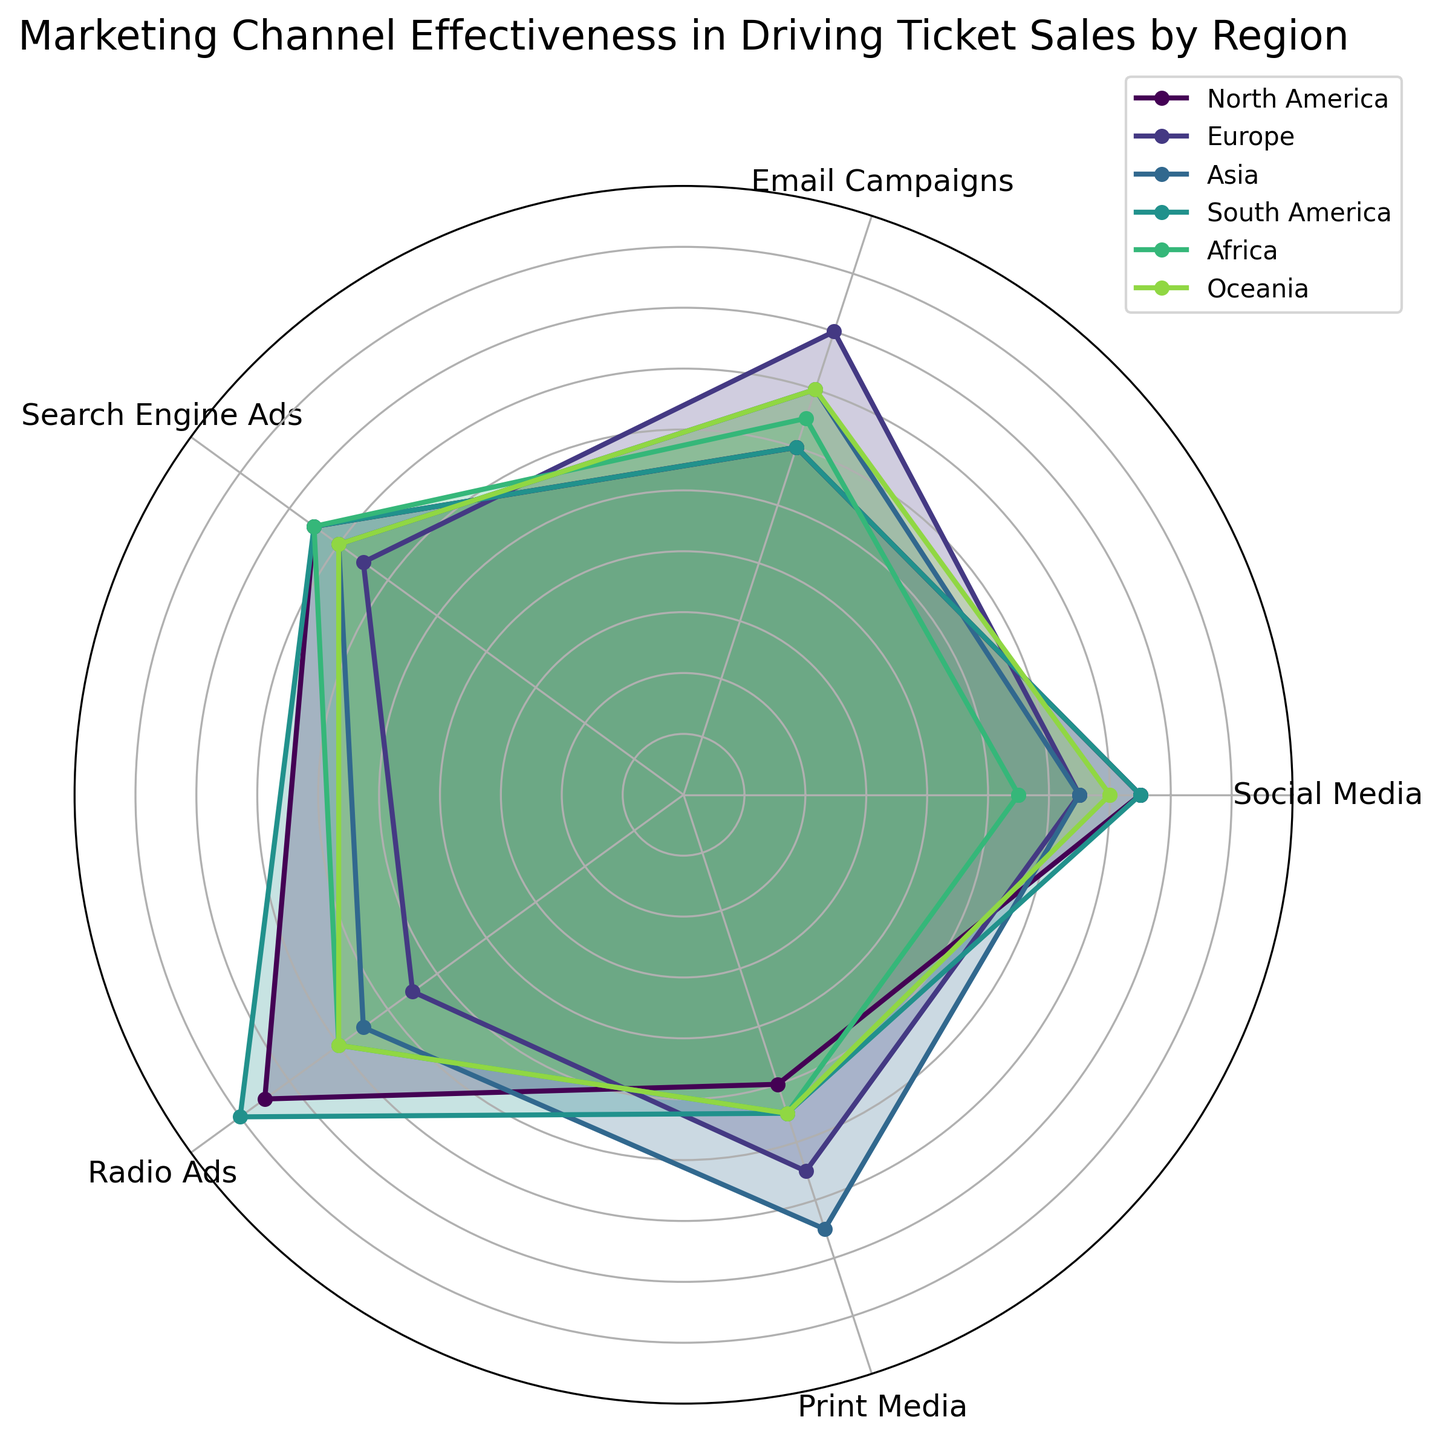What's the average effectiveness of Social Media across all regions? Sum the Social Media effectiveness values for all regions and then divide by the number of regions. The values are (7+7+8+6+5+7)/6 = 40/6 ≈ 6.67
Answer: 6.67 Which region has the highest average effectiveness across all marketing channels? Calculate the average effectiveness for each region and compare them. North America: (7+6+8+8+5)/5 = 6.8, Europe: (6+8+7+6+6)/5 = 6.6, Asia: (7+7+6+7+8)/5 = 7, South America: (8+6+7+9+5)/5 = 7, Africa: (6+7+8+6+6)/5 = 6.6, Oceania: (7+6+8+7+5)/5 = 6.6. Therefore, Asia and South America have the highest average effectiveness
Answer: Asia and South America Which marketing channel shows the highest effectiveness in North America? Look at the values for each channel in North America and identify the highest one. North America values are: Social Media = 7, Email Campaigns = 6, Search Engine Ads = 8, Radio Ads = 8, Print Media = 5. The highest value is 8 for both Search Engine Ads and Radio Ads
Answer: Search Engine Ads and Radio Ads Which region has the lowest effectiveness score for Print Media? Compare the Print Media scores across all regions. North America = 5, Europe = 6, Asia = 8, South America = 5, Africa = 6, Oceania = 5. The lowest score is 5, observed in North America, South America, and Oceania
Answer: North America, South America, Oceania Is Email Campaigns more effective in Europe or Asia based on the average scores? Compare the average Email Campaigns scores between Europe and Asia. Europe = 8, Asia = 7. Therefore, Email Campaigns are more effective in Europe
Answer: Europe How does the effectiveness of Radio Ads in Africa compare to that in Oceania? Compare the Radio Ads effectiveness values between Africa and Oceania. Africa = 6, Oceania = 7. Therefore, Radio Ads are less effective in Africa than in Oceania
Answer: Less effective in Africa In which region is Social Media more effective: South America or Oceania? Compare the Social Media effectiveness values between South America and Oceania. South America = 8, Oceania = 7. Therefore, Social Media is more effective in South America
Answer: South America Which region has the most consistent effectiveness (smallest range between channels)? Calculate the range (max - min) for each region and find the smallest. North America: 8-5 = 3, Europe: 8-6 = 2, Asia: 8-6 = 2, South America: 9-5 = 4, Africa: 8-6 = 2, Oceania: 8-5 = 3. The smallest range is 2, observed in Europe, Asia, and Africa
Answer: Europe, Asia, Africa 